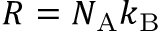Convert formula to latex. <formula><loc_0><loc_0><loc_500><loc_500>R = N _ { A } k _ { B }</formula> 